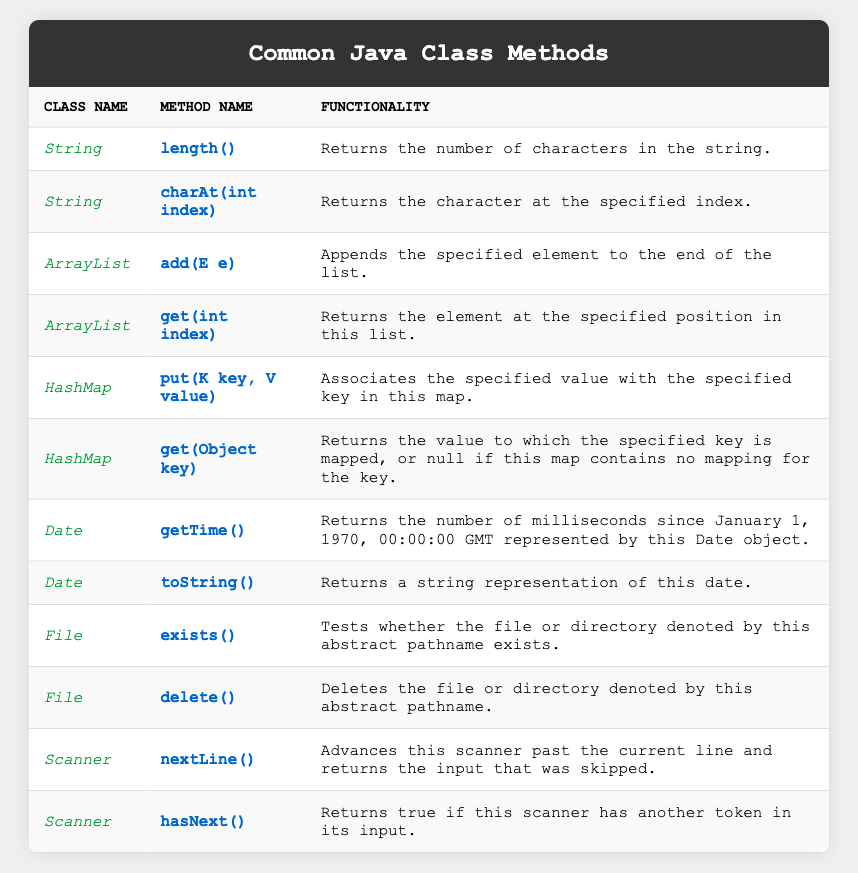What is the functionality of the `length()` method in the String class? The table shows that the `length()` method returns the number of characters in a string. This is explicitly stated in the functionality column next to the method.
Answer: Returns the number of characters in the string Which class offers a method named `add(E e)`? By scanning the table, we can see that the method `add(E e)` is listed under the ArrayList class. The method name appears in the respective row for ArrayList.
Answer: ArrayList How many methods are listed for the HashMap class? Looking at the table, there are two methods listed under the HashMap class: `put(K key, V value)` and `get(Object key)`. Counting these gives us a total of two methods.
Answer: 2 Does the Date class have a method that returns milliseconds since January 1, 1970? The table specifies that the `getTime()` method in the Date class does return the number of milliseconds since that date. This means the statement is true.
Answer: Yes What is the functionality of the `delete()` method in the File class? According to the table, the functionality described for the `delete()` method is that it deletes the file or directory denoted by the abstract pathname. This is directly extracted from the corresponding row.
Answer: Deletes the file or directory Which class has a method to check if a file exists? The table indicates that the `exists()` method is part of the File class, where it tests whether a file or directory exists. This information can be found in the respective row for File.
Answer: File How many methods in total are listed across all the classes in the table? To find the total, we can count the number of methods in each class: String has 2, ArrayList has 2, HashMap has 2, Date has 2, File has 2, and Scanner has 2, giving us a total of 12 methods (2+2+2+2+2+2 = 12).
Answer: 12 What is the purpose of the `hasNext()` method in the Scanner class? The functionality column in the table describes the `hasNext()` method as returning true if another token is available in the input. This description helps us understand its purpose.
Answer: Returns true if another token exists Which method would you use to retrieve an element by its position in an ArrayList? The table specifies that the `get(int index)` method in the ArrayList class is used to retrieve an element at a specified position. Hence, this method is the correct choice for such an operation.
Answer: get(int index) Are there more methods listed for the String class or the File class? The String class has 2 methods while the File class also has 2 methods listed. Comparing these counts indicates that both classes have the same number of methods, so neither has more.
Answer: Neither 